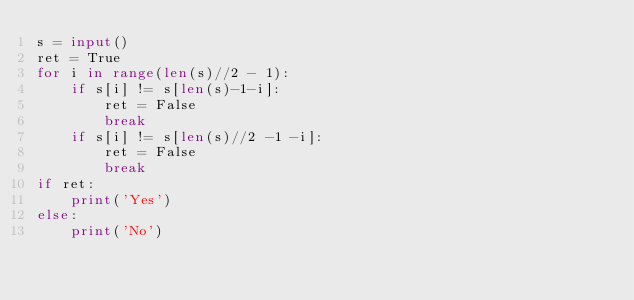Convert code to text. <code><loc_0><loc_0><loc_500><loc_500><_Python_>s = input()
ret = True
for i in range(len(s)//2 - 1):
    if s[i] != s[len(s)-1-i]:
        ret = False
        break
    if s[i] != s[len(s)//2 -1 -i]:
        ret = False
        break
if ret:
    print('Yes')
else:
    print('No')</code> 